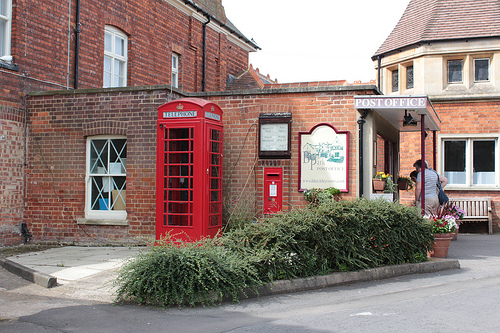<image>
Can you confirm if the telephone booth is in the bush? No. The telephone booth is not contained within the bush. These objects have a different spatial relationship. 